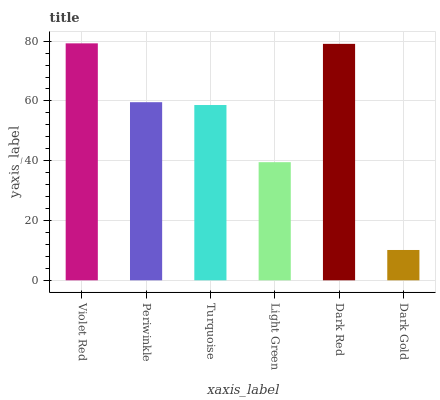Is Dark Gold the minimum?
Answer yes or no. Yes. Is Violet Red the maximum?
Answer yes or no. Yes. Is Periwinkle the minimum?
Answer yes or no. No. Is Periwinkle the maximum?
Answer yes or no. No. Is Violet Red greater than Periwinkle?
Answer yes or no. Yes. Is Periwinkle less than Violet Red?
Answer yes or no. Yes. Is Periwinkle greater than Violet Red?
Answer yes or no. No. Is Violet Red less than Periwinkle?
Answer yes or no. No. Is Periwinkle the high median?
Answer yes or no. Yes. Is Turquoise the low median?
Answer yes or no. Yes. Is Turquoise the high median?
Answer yes or no. No. Is Violet Red the low median?
Answer yes or no. No. 